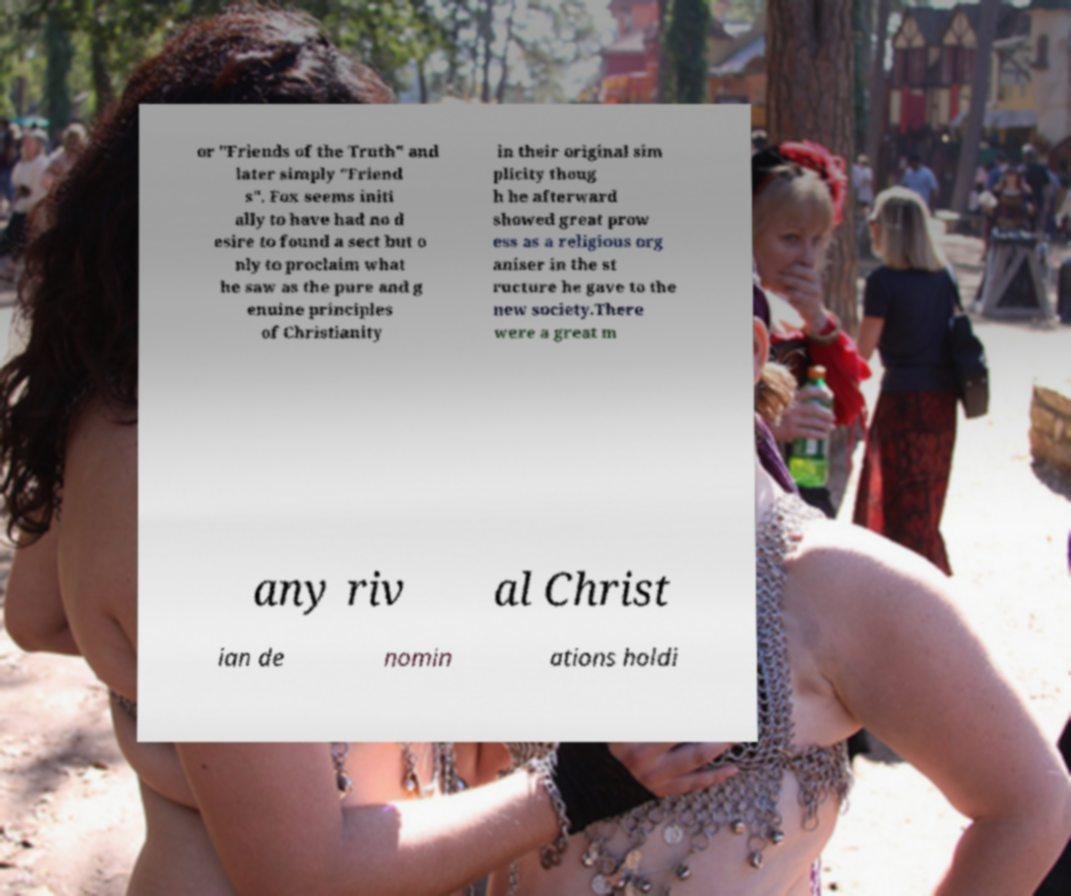For documentation purposes, I need the text within this image transcribed. Could you provide that? or "Friends of the Truth" and later simply "Friend s". Fox seems initi ally to have had no d esire to found a sect but o nly to proclaim what he saw as the pure and g enuine principles of Christianity in their original sim plicity thoug h he afterward showed great prow ess as a religious org aniser in the st ructure he gave to the new society.There were a great m any riv al Christ ian de nomin ations holdi 